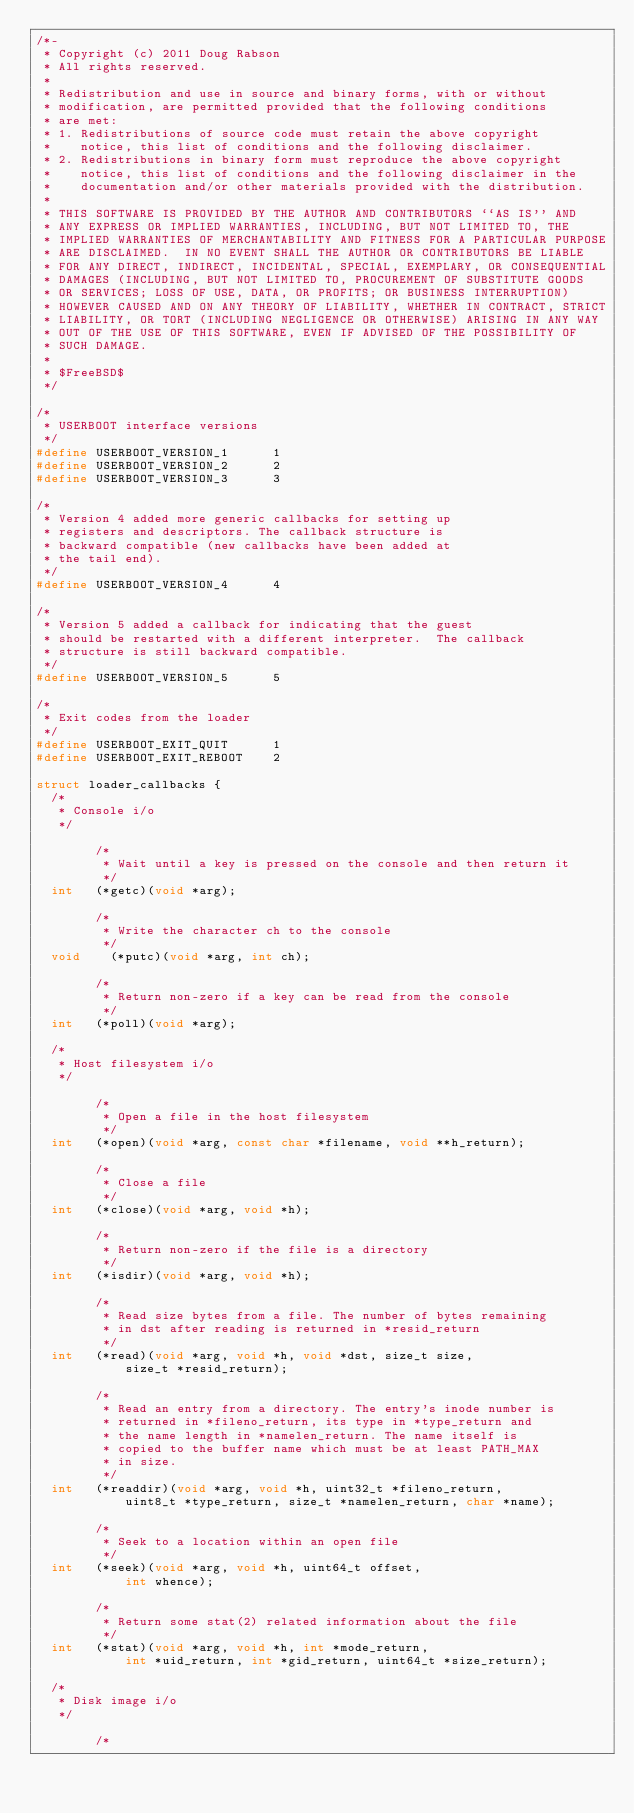<code> <loc_0><loc_0><loc_500><loc_500><_C_>/*-
 * Copyright (c) 2011 Doug Rabson
 * All rights reserved.
 *
 * Redistribution and use in source and binary forms, with or without
 * modification, are permitted provided that the following conditions
 * are met:
 * 1. Redistributions of source code must retain the above copyright
 *    notice, this list of conditions and the following disclaimer.
 * 2. Redistributions in binary form must reproduce the above copyright
 *    notice, this list of conditions and the following disclaimer in the
 *    documentation and/or other materials provided with the distribution.
 *
 * THIS SOFTWARE IS PROVIDED BY THE AUTHOR AND CONTRIBUTORS ``AS IS'' AND
 * ANY EXPRESS OR IMPLIED WARRANTIES, INCLUDING, BUT NOT LIMITED TO, THE
 * IMPLIED WARRANTIES OF MERCHANTABILITY AND FITNESS FOR A PARTICULAR PURPOSE
 * ARE DISCLAIMED.  IN NO EVENT SHALL THE AUTHOR OR CONTRIBUTORS BE LIABLE
 * FOR ANY DIRECT, INDIRECT, INCIDENTAL, SPECIAL, EXEMPLARY, OR CONSEQUENTIAL
 * DAMAGES (INCLUDING, BUT NOT LIMITED TO, PROCUREMENT OF SUBSTITUTE GOODS
 * OR SERVICES; LOSS OF USE, DATA, OR PROFITS; OR BUSINESS INTERRUPTION)
 * HOWEVER CAUSED AND ON ANY THEORY OF LIABILITY, WHETHER IN CONTRACT, STRICT
 * LIABILITY, OR TORT (INCLUDING NEGLIGENCE OR OTHERWISE) ARISING IN ANY WAY
 * OUT OF THE USE OF THIS SOFTWARE, EVEN IF ADVISED OF THE POSSIBILITY OF
 * SUCH DAMAGE.
 *
 * $FreeBSD$
 */

/*
 * USERBOOT interface versions
 */
#define	USERBOOT_VERSION_1      1
#define	USERBOOT_VERSION_2      2
#define	USERBOOT_VERSION_3      3

/*
 * Version 4 added more generic callbacks for setting up
 * registers and descriptors. The callback structure is
 * backward compatible (new callbacks have been added at
 * the tail end).
 */
#define	USERBOOT_VERSION_4      4

/*
 * Version 5 added a callback for indicating that the guest
 * should be restarted with a different interpreter.  The callback
 * structure is still backward compatible.
 */
#define	USERBOOT_VERSION_5      5

/*
 * Exit codes from the loader
 */
#define	USERBOOT_EXIT_QUIT      1
#define	USERBOOT_EXIT_REBOOT    2

struct loader_callbacks {
	/*
	 * Console i/o
	 */

        /*
         * Wait until a key is pressed on the console and then return it
         */
	int		(*getc)(void *arg);

        /*
         * Write the character ch to the console
         */
	void		(*putc)(void *arg, int ch);

        /*
         * Return non-zero if a key can be read from the console
         */
	int		(*poll)(void *arg);

	/*
	 * Host filesystem i/o
	 */

        /*
         * Open a file in the host filesystem
         */
	int		(*open)(void *arg, const char *filename, void **h_return);

        /*
         * Close a file
         */
	int		(*close)(void *arg, void *h);

        /*
         * Return non-zero if the file is a directory
         */
	int		(*isdir)(void *arg, void *h);

        /*
         * Read size bytes from a file. The number of bytes remaining
         * in dst after reading is returned in *resid_return
         */
	int		(*read)(void *arg, void *h, void *dst, size_t size,
            size_t *resid_return);

        /*
         * Read an entry from a directory. The entry's inode number is
         * returned in *fileno_return, its type in *type_return and
         * the name length in *namelen_return. The name itself is
         * copied to the buffer name which must be at least PATH_MAX
         * in size.
         */
	int		(*readdir)(void *arg, void *h, uint32_t *fileno_return,
            uint8_t *type_return, size_t *namelen_return, char *name);

        /*
         * Seek to a location within an open file
         */
	int		(*seek)(void *arg, void *h, uint64_t offset,
            int whence);

        /*
         * Return some stat(2) related information about the file
         */
	int		(*stat)(void *arg, void *h, int *mode_return,
            int *uid_return, int *gid_return, uint64_t *size_return);

	/*
	 * Disk image i/o
	 */

        /*</code> 